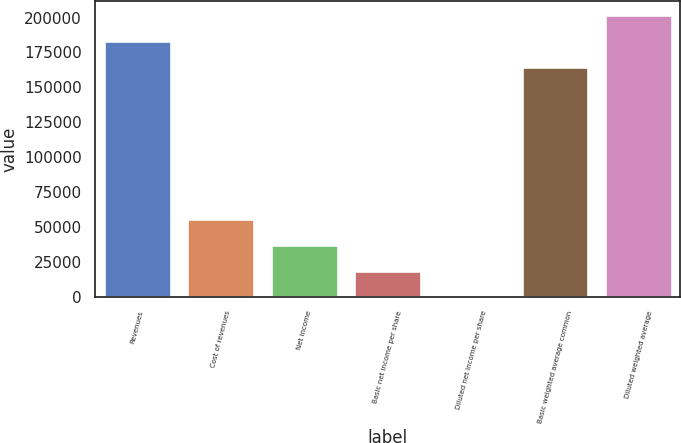Convert chart. <chart><loc_0><loc_0><loc_500><loc_500><bar_chart><fcel>Revenues<fcel>Cost of revenues<fcel>Net income<fcel>Basic net income per share<fcel>Diluted net income per share<fcel>Basic weighted average common<fcel>Diluted weighted average<nl><fcel>183297<fcel>55588.3<fcel>37059<fcel>18529.6<fcel>0.2<fcel>164768<fcel>201827<nl></chart> 